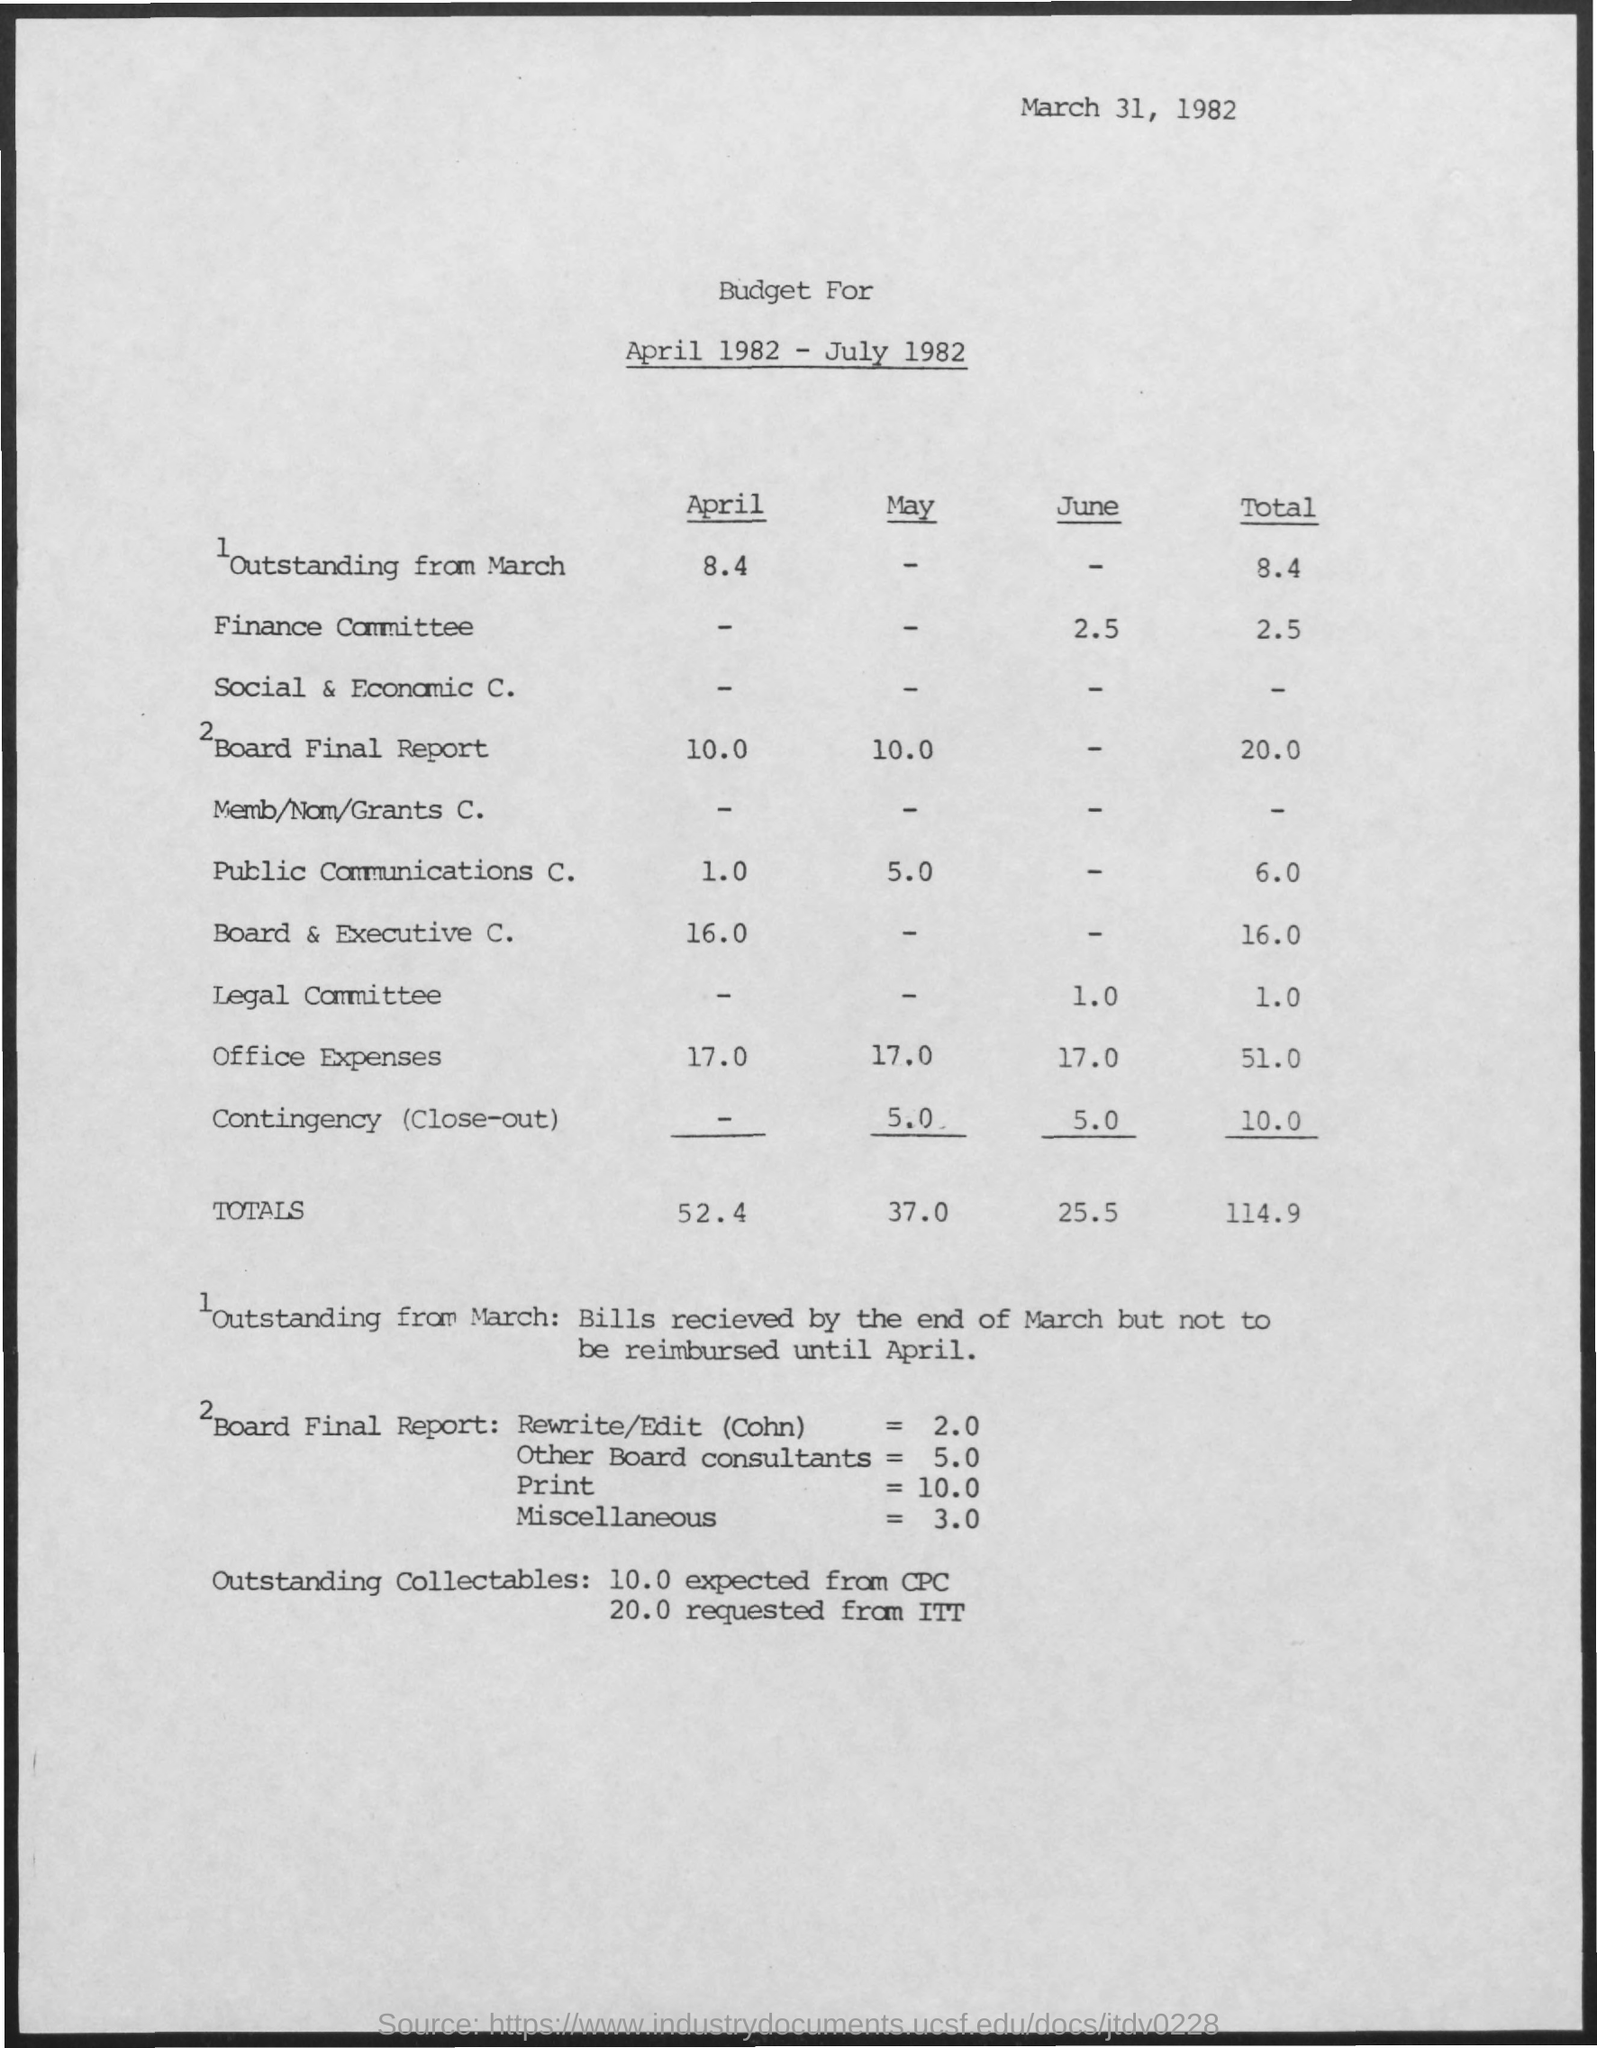Indicate a few pertinent items in this graphic. The total for April is 52.4. The outstanding amount for March total is 8.4. The budget for the Board Final Report in April is 10.0... The total for May is 37.0. The total for June is 25.5. 